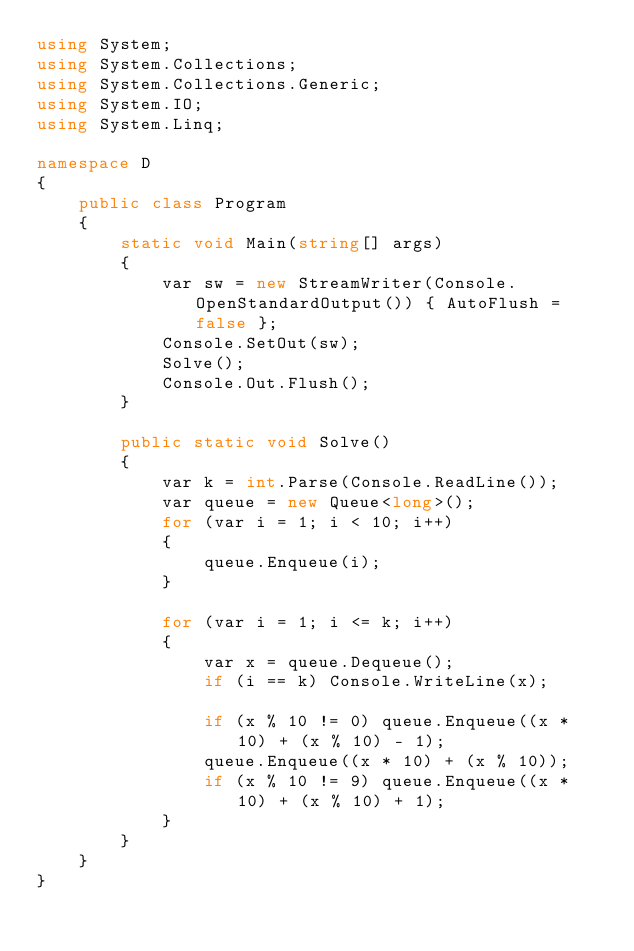<code> <loc_0><loc_0><loc_500><loc_500><_C#_>using System;
using System.Collections;
using System.Collections.Generic;
using System.IO;
using System.Linq;

namespace D
{
    public class Program
    {
        static void Main(string[] args)
        {
            var sw = new StreamWriter(Console.OpenStandardOutput()) { AutoFlush = false };
            Console.SetOut(sw);
            Solve();
            Console.Out.Flush();
        }

        public static void Solve()
        {
            var k = int.Parse(Console.ReadLine());
            var queue = new Queue<long>();
            for (var i = 1; i < 10; i++)
            {
                queue.Enqueue(i);
            }

            for (var i = 1; i <= k; i++)
            {
                var x = queue.Dequeue();
                if (i == k) Console.WriteLine(x);

                if (x % 10 != 0) queue.Enqueue((x * 10) + (x % 10) - 1);
                queue.Enqueue((x * 10) + (x % 10));
                if (x % 10 != 9) queue.Enqueue((x * 10) + (x % 10) + 1);
            }
        }
    }
}
</code> 